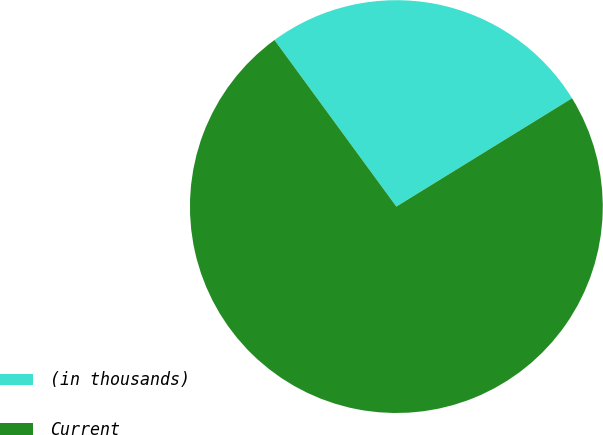Convert chart. <chart><loc_0><loc_0><loc_500><loc_500><pie_chart><fcel>(in thousands)<fcel>Current<nl><fcel>26.26%<fcel>73.74%<nl></chart> 